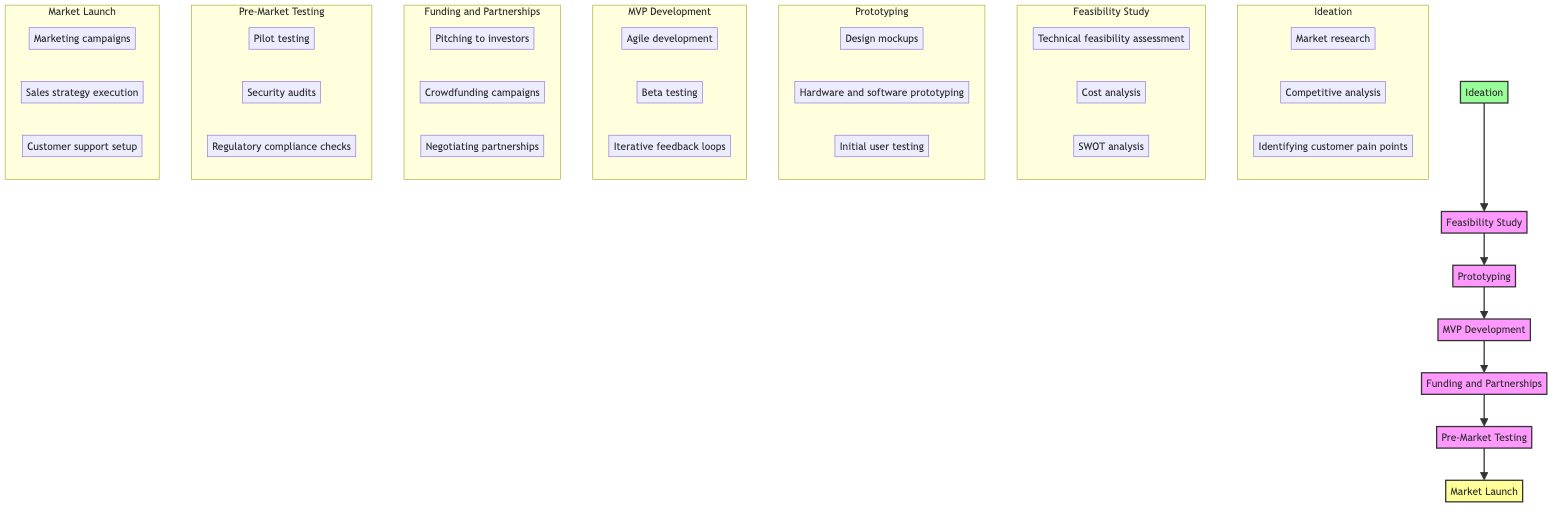What is the first step in the product development lifecycle? The first step in the product development lifecycle is Ideation, which involves brainstorming and conceptualizing innovative ideas for a new product.
Answer: Ideation How many key activities are there in the Prototyping phase? In the Prototyping phase, there are three key activities: design mockups, hardware and software prototyping, and initial user testing.
Answer: Three Which actors are involved in the MVP Development phase? The actors involved in the MVP Development phase include the Development Team, Quality Assurance Team, and Early Adopters.
Answer: Development Team, Quality Assurance Team, Early Adopters What is the last phase before Market Launch? The last phase before Market Launch is Pre-Market Testing, which ensures product stability, security, and compliance with standards.
Answer: Pre-Market Testing Which phase comes after Funding and Partnerships? The phase that comes after Funding and Partnerships is Pre-Market Testing, indicating that secure funding and partnerships are essential before testing the product.
Answer: Pre-Market Testing What is the purpose of the MVP Development phase? The purpose of the MVP Development phase is to create a Minimum Viable Product to test the market with core features, ensuring that the product meets user needs.
Answer: Create a Minimum Viable Product What is the correlation between Ideation and Feasibility Study? The correlation between Ideation and Feasibility Study is that the ideas generated in the Ideation phase need to be assessed for their technical, financial, and market feasibility in the subsequent Feasibility Study phase.
Answer: Assessment of feasibility Which elements contribute to securing necessary funds in the Funding and Partnerships phase? In the Funding and Partnerships phase, the activities contributing to securing funds include pitching to investors, crowdfunding campaigns, and negotiating partnerships.
Answer: Pitching to investors, crowdfunding campaigns, negotiating partnerships How are the actors in the Pre-Market Testing phase categorized? The actors in the Pre-Market Testing phase are categorized as QA Engineers, Security Experts, and Compliance Officers, highlighting their roles in ensuring readiness for market launch.
Answer: QA Engineers, Security Experts, Compliance Officers 